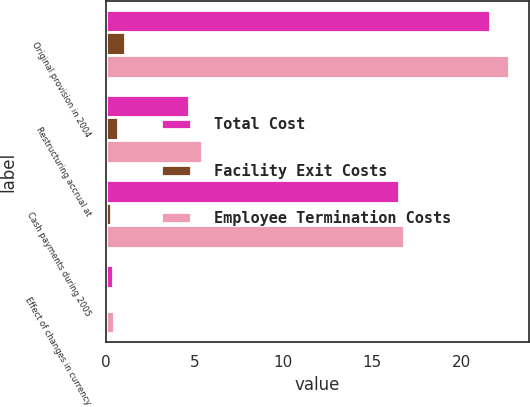Convert chart. <chart><loc_0><loc_0><loc_500><loc_500><stacked_bar_chart><ecel><fcel>Original provision in 2004<fcel>Restructuring accrual at<fcel>Cash payments during 2005<fcel>Effect of changes in currency<nl><fcel>Total Cost<fcel>21.6<fcel>4.7<fcel>16.5<fcel>0.4<nl><fcel>Facility Exit Costs<fcel>1.1<fcel>0.7<fcel>0.3<fcel>0.1<nl><fcel>Employee Termination Costs<fcel>22.7<fcel>5.4<fcel>16.8<fcel>0.5<nl></chart> 